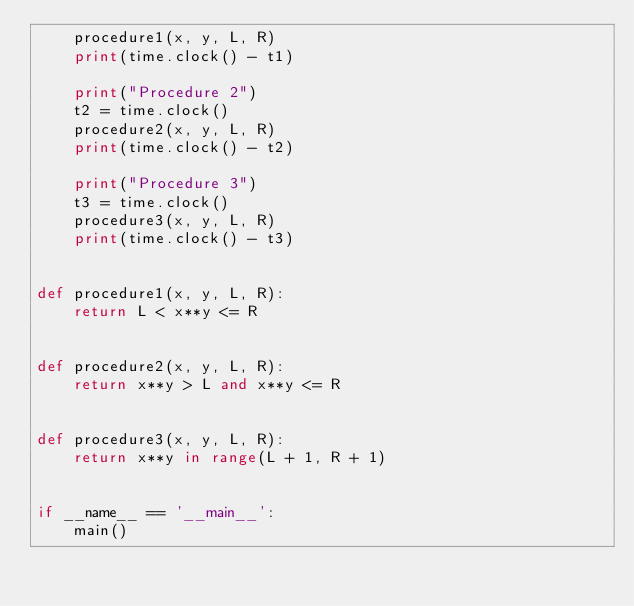Convert code to text. <code><loc_0><loc_0><loc_500><loc_500><_Python_>    procedure1(x, y, L, R)
    print(time.clock() - t1)

    print("Procedure 2")
    t2 = time.clock()
    procedure2(x, y, L, R)
    print(time.clock() - t2)

    print("Procedure 3")
    t3 = time.clock()
    procedure3(x, y, L, R)
    print(time.clock() - t3)


def procedure1(x, y, L, R):
    return L < x**y <= R


def procedure2(x, y, L, R):
    return x**y > L and x**y <= R


def procedure3(x, y, L, R):
    return x**y in range(L + 1, R + 1)


if __name__ == '__main__':
    main()
</code> 